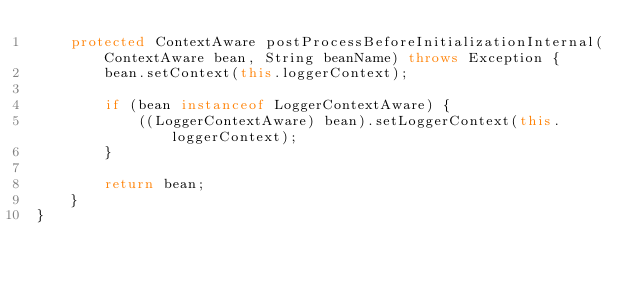<code> <loc_0><loc_0><loc_500><loc_500><_Java_>    protected ContextAware postProcessBeforeInitializationInternal(ContextAware bean, String beanName) throws Exception {
        bean.setContext(this.loggerContext);

        if (bean instanceof LoggerContextAware) {
            ((LoggerContextAware) bean).setLoggerContext(this.loggerContext);
        }

        return bean;
    }
}
</code> 